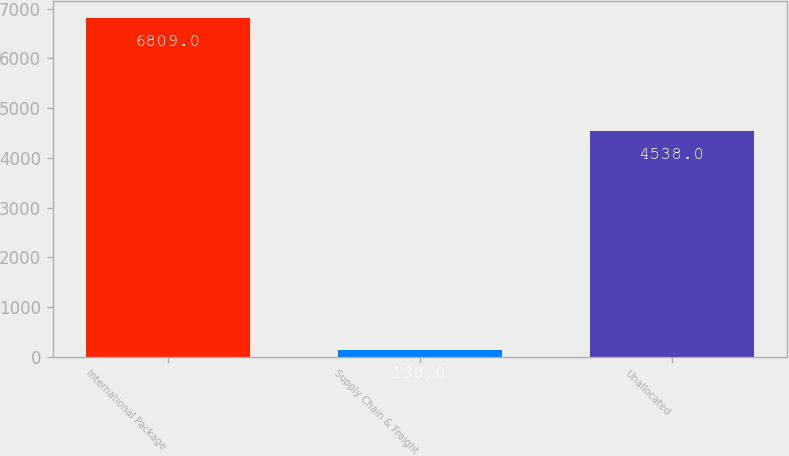Convert chart to OTSL. <chart><loc_0><loc_0><loc_500><loc_500><bar_chart><fcel>International Package<fcel>Supply Chain & Freight<fcel>Unallocated<nl><fcel>6809<fcel>138<fcel>4538<nl></chart> 